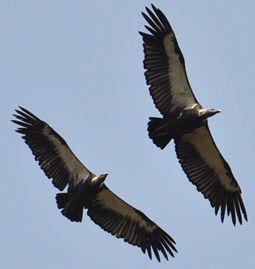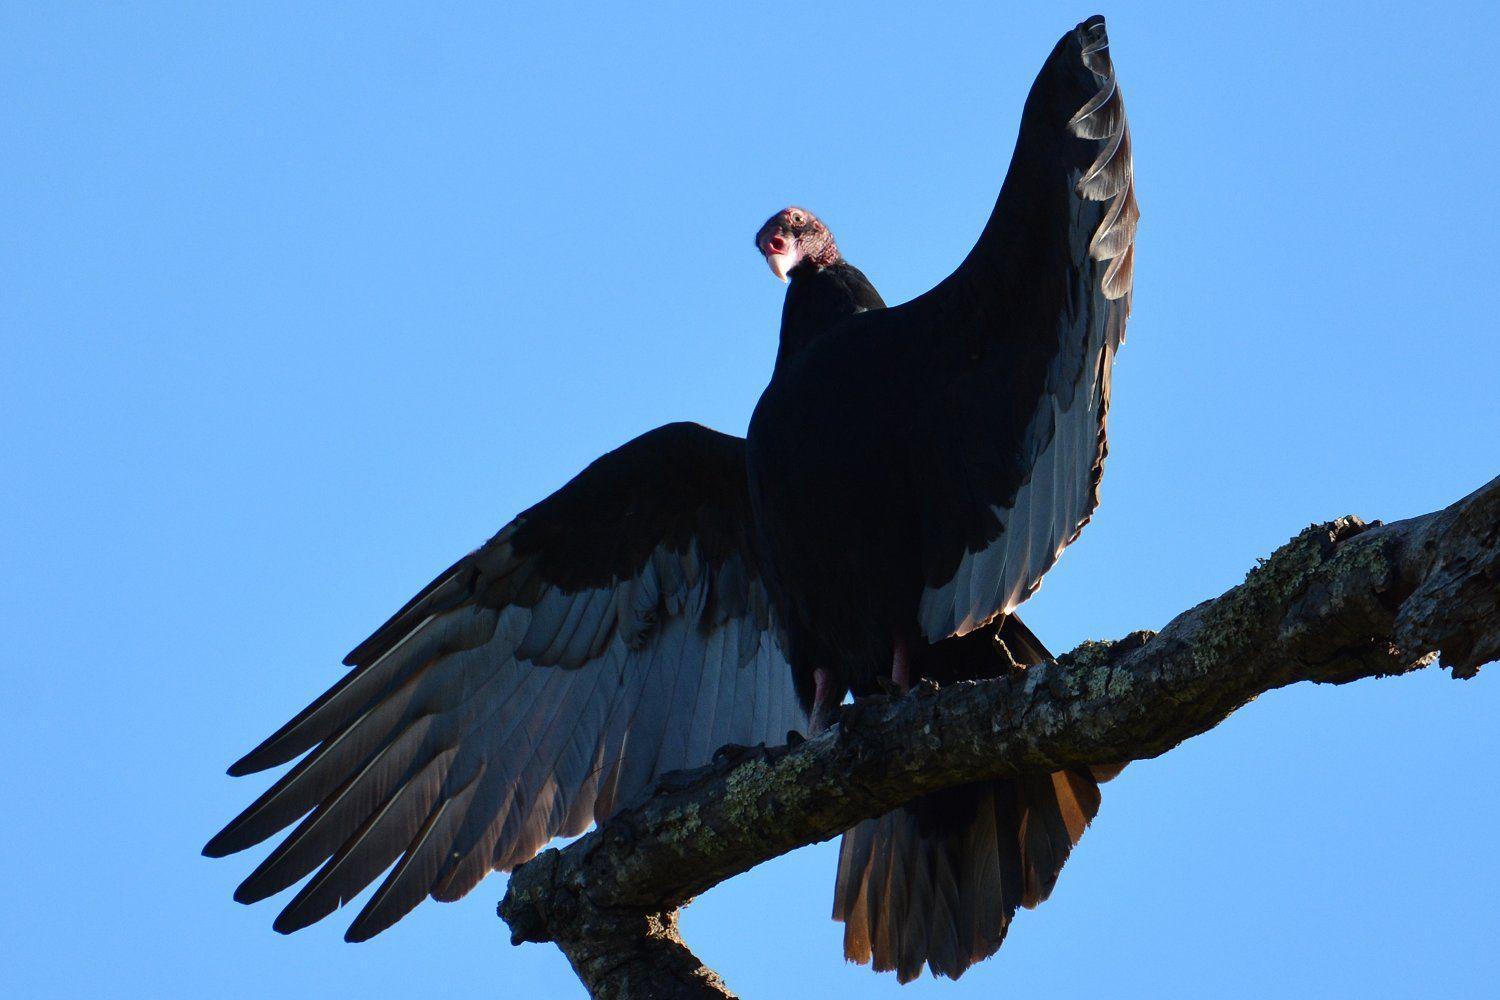The first image is the image on the left, the second image is the image on the right. Evaluate the accuracy of this statement regarding the images: "At least one bird is flying in the air.". Is it true? Answer yes or no. Yes. 